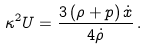<formula> <loc_0><loc_0><loc_500><loc_500>\kappa ^ { 2 } U = \frac { 3 \left ( \rho + p \right ) \dot { x } } { 4 \dot { \rho } } \, .</formula> 